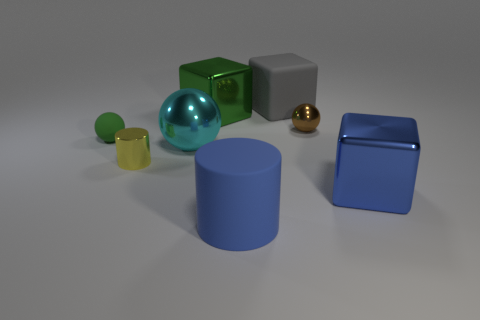Add 1 big cylinders. How many objects exist? 9 Subtract all balls. How many objects are left? 5 Subtract 0 gray cylinders. How many objects are left? 8 Subtract all big blue rubber objects. Subtract all large green things. How many objects are left? 6 Add 7 yellow cylinders. How many yellow cylinders are left? 8 Add 3 blue matte things. How many blue matte things exist? 4 